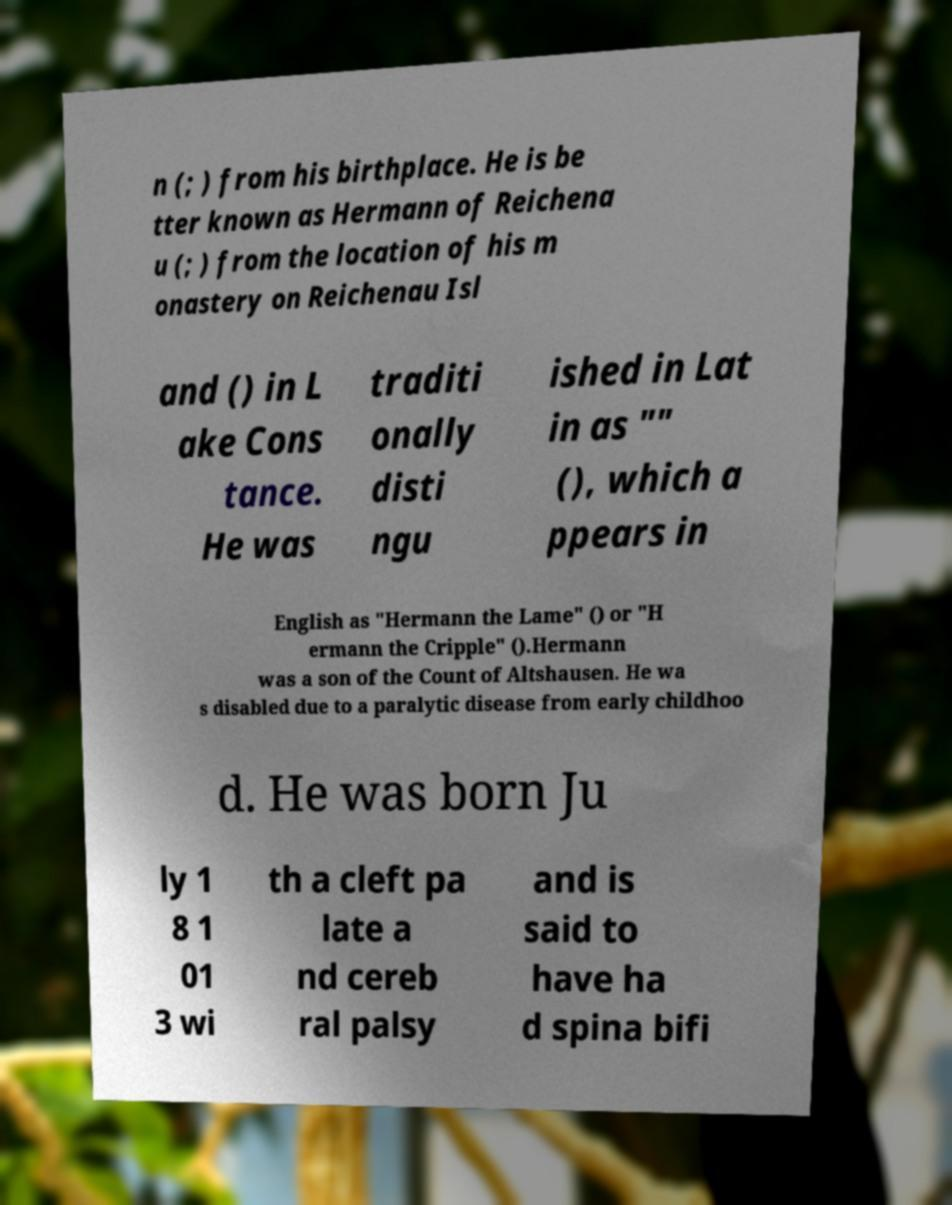There's text embedded in this image that I need extracted. Can you transcribe it verbatim? n (; ) from his birthplace. He is be tter known as Hermann of Reichena u (; ) from the location of his m onastery on Reichenau Isl and () in L ake Cons tance. He was traditi onally disti ngu ished in Lat in as "" (), which a ppears in English as "Hermann the Lame" () or "H ermann the Cripple" ().Hermann was a son of the Count of Altshausen. He wa s disabled due to a paralytic disease from early childhoo d. He was born Ju ly 1 8 1 01 3 wi th a cleft pa late a nd cereb ral palsy and is said to have ha d spina bifi 